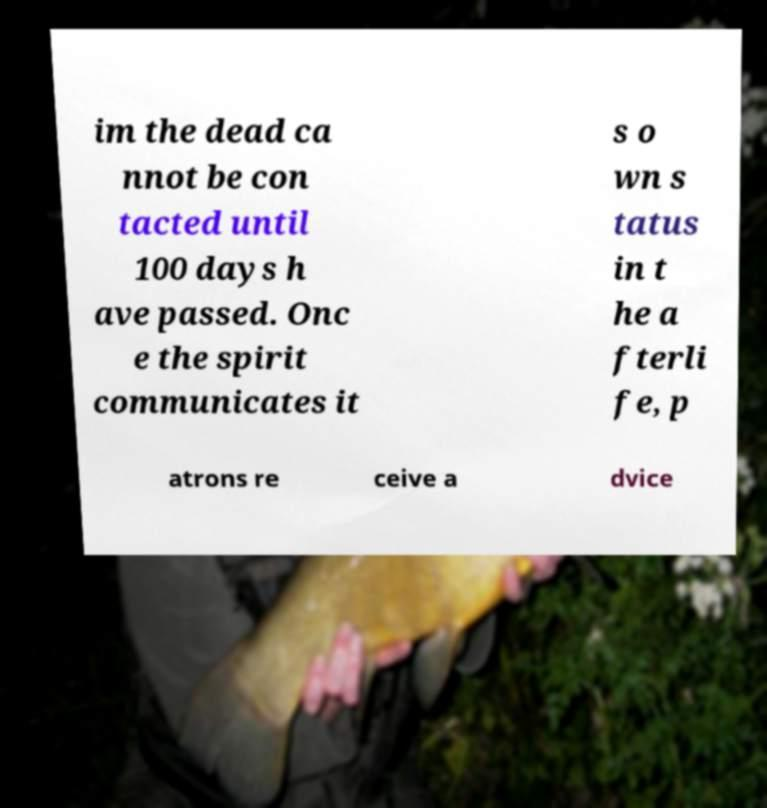Can you accurately transcribe the text from the provided image for me? im the dead ca nnot be con tacted until 100 days h ave passed. Onc e the spirit communicates it s o wn s tatus in t he a fterli fe, p atrons re ceive a dvice 